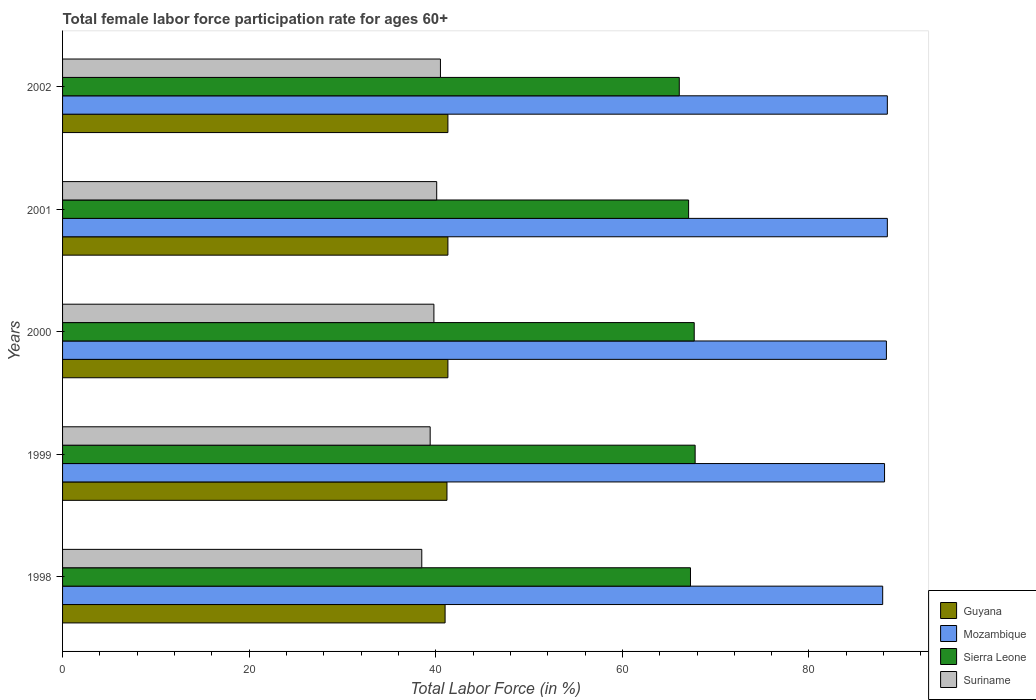How many groups of bars are there?
Your answer should be very brief. 5. Are the number of bars per tick equal to the number of legend labels?
Offer a very short reply. Yes. Are the number of bars on each tick of the Y-axis equal?
Provide a short and direct response. Yes. How many bars are there on the 2nd tick from the top?
Your answer should be very brief. 4. How many bars are there on the 5th tick from the bottom?
Give a very brief answer. 4. In how many cases, is the number of bars for a given year not equal to the number of legend labels?
Offer a very short reply. 0. What is the female labor force participation rate in Sierra Leone in 2000?
Your answer should be compact. 67.7. Across all years, what is the maximum female labor force participation rate in Sierra Leone?
Offer a very short reply. 67.8. Across all years, what is the minimum female labor force participation rate in Mozambique?
Offer a terse response. 87.9. In which year was the female labor force participation rate in Guyana minimum?
Give a very brief answer. 1998. What is the total female labor force participation rate in Guyana in the graph?
Give a very brief answer. 206.1. What is the difference between the female labor force participation rate in Mozambique in 2001 and that in 2002?
Your response must be concise. 0. What is the difference between the female labor force participation rate in Guyana in 1998 and the female labor force participation rate in Mozambique in 1999?
Make the answer very short. -47.1. What is the average female labor force participation rate in Sierra Leone per year?
Provide a succinct answer. 67.2. In the year 1998, what is the difference between the female labor force participation rate in Mozambique and female labor force participation rate in Sierra Leone?
Provide a succinct answer. 20.6. In how many years, is the female labor force participation rate in Guyana greater than 40 %?
Offer a very short reply. 5. What is the ratio of the female labor force participation rate in Guyana in 2000 to that in 2001?
Provide a short and direct response. 1. Is the difference between the female labor force participation rate in Mozambique in 2000 and 2002 greater than the difference between the female labor force participation rate in Sierra Leone in 2000 and 2002?
Your answer should be very brief. No. What is the difference between the highest and the second highest female labor force participation rate in Mozambique?
Your response must be concise. 0. What is the difference between the highest and the lowest female labor force participation rate in Suriname?
Keep it short and to the point. 2. In how many years, is the female labor force participation rate in Sierra Leone greater than the average female labor force participation rate in Sierra Leone taken over all years?
Give a very brief answer. 3. Is it the case that in every year, the sum of the female labor force participation rate in Sierra Leone and female labor force participation rate in Mozambique is greater than the sum of female labor force participation rate in Suriname and female labor force participation rate in Guyana?
Your answer should be compact. Yes. What does the 3rd bar from the top in 2001 represents?
Your answer should be compact. Mozambique. What does the 1st bar from the bottom in 2001 represents?
Offer a very short reply. Guyana. How many years are there in the graph?
Keep it short and to the point. 5. What is the difference between two consecutive major ticks on the X-axis?
Your answer should be compact. 20. Are the values on the major ticks of X-axis written in scientific E-notation?
Give a very brief answer. No. Does the graph contain grids?
Provide a succinct answer. No. Where does the legend appear in the graph?
Offer a very short reply. Bottom right. How many legend labels are there?
Provide a short and direct response. 4. How are the legend labels stacked?
Provide a succinct answer. Vertical. What is the title of the graph?
Make the answer very short. Total female labor force participation rate for ages 60+. What is the Total Labor Force (in %) of Guyana in 1998?
Ensure brevity in your answer.  41. What is the Total Labor Force (in %) in Mozambique in 1998?
Offer a terse response. 87.9. What is the Total Labor Force (in %) of Sierra Leone in 1998?
Your answer should be very brief. 67.3. What is the Total Labor Force (in %) in Suriname in 1998?
Give a very brief answer. 38.5. What is the Total Labor Force (in %) in Guyana in 1999?
Provide a short and direct response. 41.2. What is the Total Labor Force (in %) of Mozambique in 1999?
Give a very brief answer. 88.1. What is the Total Labor Force (in %) of Sierra Leone in 1999?
Provide a succinct answer. 67.8. What is the Total Labor Force (in %) in Suriname in 1999?
Provide a succinct answer. 39.4. What is the Total Labor Force (in %) in Guyana in 2000?
Offer a very short reply. 41.3. What is the Total Labor Force (in %) in Mozambique in 2000?
Provide a short and direct response. 88.3. What is the Total Labor Force (in %) of Sierra Leone in 2000?
Your answer should be very brief. 67.7. What is the Total Labor Force (in %) of Suriname in 2000?
Make the answer very short. 39.8. What is the Total Labor Force (in %) of Guyana in 2001?
Ensure brevity in your answer.  41.3. What is the Total Labor Force (in %) in Mozambique in 2001?
Your response must be concise. 88.4. What is the Total Labor Force (in %) in Sierra Leone in 2001?
Give a very brief answer. 67.1. What is the Total Labor Force (in %) of Suriname in 2001?
Keep it short and to the point. 40.1. What is the Total Labor Force (in %) in Guyana in 2002?
Keep it short and to the point. 41.3. What is the Total Labor Force (in %) of Mozambique in 2002?
Offer a very short reply. 88.4. What is the Total Labor Force (in %) in Sierra Leone in 2002?
Ensure brevity in your answer.  66.1. What is the Total Labor Force (in %) of Suriname in 2002?
Offer a very short reply. 40.5. Across all years, what is the maximum Total Labor Force (in %) of Guyana?
Offer a terse response. 41.3. Across all years, what is the maximum Total Labor Force (in %) of Mozambique?
Keep it short and to the point. 88.4. Across all years, what is the maximum Total Labor Force (in %) in Sierra Leone?
Your response must be concise. 67.8. Across all years, what is the maximum Total Labor Force (in %) of Suriname?
Keep it short and to the point. 40.5. Across all years, what is the minimum Total Labor Force (in %) in Guyana?
Keep it short and to the point. 41. Across all years, what is the minimum Total Labor Force (in %) of Mozambique?
Your answer should be very brief. 87.9. Across all years, what is the minimum Total Labor Force (in %) of Sierra Leone?
Give a very brief answer. 66.1. Across all years, what is the minimum Total Labor Force (in %) in Suriname?
Give a very brief answer. 38.5. What is the total Total Labor Force (in %) in Guyana in the graph?
Give a very brief answer. 206.1. What is the total Total Labor Force (in %) in Mozambique in the graph?
Your response must be concise. 441.1. What is the total Total Labor Force (in %) of Sierra Leone in the graph?
Your answer should be compact. 336. What is the total Total Labor Force (in %) of Suriname in the graph?
Keep it short and to the point. 198.3. What is the difference between the Total Labor Force (in %) of Guyana in 1998 and that in 1999?
Your answer should be very brief. -0.2. What is the difference between the Total Labor Force (in %) of Mozambique in 1998 and that in 1999?
Your response must be concise. -0.2. What is the difference between the Total Labor Force (in %) in Suriname in 1998 and that in 1999?
Provide a succinct answer. -0.9. What is the difference between the Total Labor Force (in %) of Guyana in 1998 and that in 2000?
Ensure brevity in your answer.  -0.3. What is the difference between the Total Labor Force (in %) in Mozambique in 1998 and that in 2000?
Your answer should be compact. -0.4. What is the difference between the Total Labor Force (in %) of Sierra Leone in 1998 and that in 2000?
Offer a very short reply. -0.4. What is the difference between the Total Labor Force (in %) of Guyana in 1998 and that in 2001?
Ensure brevity in your answer.  -0.3. What is the difference between the Total Labor Force (in %) of Sierra Leone in 1998 and that in 2001?
Offer a very short reply. 0.2. What is the difference between the Total Labor Force (in %) in Suriname in 1998 and that in 2001?
Offer a very short reply. -1.6. What is the difference between the Total Labor Force (in %) of Sierra Leone in 1998 and that in 2002?
Keep it short and to the point. 1.2. What is the difference between the Total Labor Force (in %) of Sierra Leone in 1999 and that in 2000?
Provide a short and direct response. 0.1. What is the difference between the Total Labor Force (in %) of Guyana in 1999 and that in 2001?
Your response must be concise. -0.1. What is the difference between the Total Labor Force (in %) in Sierra Leone in 1999 and that in 2001?
Offer a terse response. 0.7. What is the difference between the Total Labor Force (in %) in Guyana in 1999 and that in 2002?
Your answer should be very brief. -0.1. What is the difference between the Total Labor Force (in %) in Mozambique in 1999 and that in 2002?
Ensure brevity in your answer.  -0.3. What is the difference between the Total Labor Force (in %) of Mozambique in 2000 and that in 2001?
Give a very brief answer. -0.1. What is the difference between the Total Labor Force (in %) of Suriname in 2000 and that in 2001?
Your answer should be very brief. -0.3. What is the difference between the Total Labor Force (in %) in Guyana in 2000 and that in 2002?
Ensure brevity in your answer.  0. What is the difference between the Total Labor Force (in %) in Suriname in 2000 and that in 2002?
Provide a succinct answer. -0.7. What is the difference between the Total Labor Force (in %) of Guyana in 2001 and that in 2002?
Provide a succinct answer. 0. What is the difference between the Total Labor Force (in %) in Sierra Leone in 2001 and that in 2002?
Your answer should be very brief. 1. What is the difference between the Total Labor Force (in %) in Suriname in 2001 and that in 2002?
Provide a succinct answer. -0.4. What is the difference between the Total Labor Force (in %) of Guyana in 1998 and the Total Labor Force (in %) of Mozambique in 1999?
Provide a short and direct response. -47.1. What is the difference between the Total Labor Force (in %) of Guyana in 1998 and the Total Labor Force (in %) of Sierra Leone in 1999?
Provide a succinct answer. -26.8. What is the difference between the Total Labor Force (in %) of Mozambique in 1998 and the Total Labor Force (in %) of Sierra Leone in 1999?
Make the answer very short. 20.1. What is the difference between the Total Labor Force (in %) of Mozambique in 1998 and the Total Labor Force (in %) of Suriname in 1999?
Provide a succinct answer. 48.5. What is the difference between the Total Labor Force (in %) in Sierra Leone in 1998 and the Total Labor Force (in %) in Suriname in 1999?
Give a very brief answer. 27.9. What is the difference between the Total Labor Force (in %) in Guyana in 1998 and the Total Labor Force (in %) in Mozambique in 2000?
Keep it short and to the point. -47.3. What is the difference between the Total Labor Force (in %) in Guyana in 1998 and the Total Labor Force (in %) in Sierra Leone in 2000?
Keep it short and to the point. -26.7. What is the difference between the Total Labor Force (in %) in Mozambique in 1998 and the Total Labor Force (in %) in Sierra Leone in 2000?
Make the answer very short. 20.2. What is the difference between the Total Labor Force (in %) in Mozambique in 1998 and the Total Labor Force (in %) in Suriname in 2000?
Offer a very short reply. 48.1. What is the difference between the Total Labor Force (in %) in Sierra Leone in 1998 and the Total Labor Force (in %) in Suriname in 2000?
Your answer should be very brief. 27.5. What is the difference between the Total Labor Force (in %) of Guyana in 1998 and the Total Labor Force (in %) of Mozambique in 2001?
Your response must be concise. -47.4. What is the difference between the Total Labor Force (in %) of Guyana in 1998 and the Total Labor Force (in %) of Sierra Leone in 2001?
Give a very brief answer. -26.1. What is the difference between the Total Labor Force (in %) in Guyana in 1998 and the Total Labor Force (in %) in Suriname in 2001?
Provide a succinct answer. 0.9. What is the difference between the Total Labor Force (in %) in Mozambique in 1998 and the Total Labor Force (in %) in Sierra Leone in 2001?
Make the answer very short. 20.8. What is the difference between the Total Labor Force (in %) of Mozambique in 1998 and the Total Labor Force (in %) of Suriname in 2001?
Your answer should be compact. 47.8. What is the difference between the Total Labor Force (in %) in Sierra Leone in 1998 and the Total Labor Force (in %) in Suriname in 2001?
Your answer should be very brief. 27.2. What is the difference between the Total Labor Force (in %) of Guyana in 1998 and the Total Labor Force (in %) of Mozambique in 2002?
Your response must be concise. -47.4. What is the difference between the Total Labor Force (in %) in Guyana in 1998 and the Total Labor Force (in %) in Sierra Leone in 2002?
Offer a very short reply. -25.1. What is the difference between the Total Labor Force (in %) of Guyana in 1998 and the Total Labor Force (in %) of Suriname in 2002?
Your response must be concise. 0.5. What is the difference between the Total Labor Force (in %) in Mozambique in 1998 and the Total Labor Force (in %) in Sierra Leone in 2002?
Your answer should be very brief. 21.8. What is the difference between the Total Labor Force (in %) in Mozambique in 1998 and the Total Labor Force (in %) in Suriname in 2002?
Your answer should be compact. 47.4. What is the difference between the Total Labor Force (in %) of Sierra Leone in 1998 and the Total Labor Force (in %) of Suriname in 2002?
Your answer should be very brief. 26.8. What is the difference between the Total Labor Force (in %) in Guyana in 1999 and the Total Labor Force (in %) in Mozambique in 2000?
Ensure brevity in your answer.  -47.1. What is the difference between the Total Labor Force (in %) of Guyana in 1999 and the Total Labor Force (in %) of Sierra Leone in 2000?
Offer a very short reply. -26.5. What is the difference between the Total Labor Force (in %) in Guyana in 1999 and the Total Labor Force (in %) in Suriname in 2000?
Ensure brevity in your answer.  1.4. What is the difference between the Total Labor Force (in %) of Mozambique in 1999 and the Total Labor Force (in %) of Sierra Leone in 2000?
Your answer should be compact. 20.4. What is the difference between the Total Labor Force (in %) in Mozambique in 1999 and the Total Labor Force (in %) in Suriname in 2000?
Your response must be concise. 48.3. What is the difference between the Total Labor Force (in %) in Guyana in 1999 and the Total Labor Force (in %) in Mozambique in 2001?
Provide a short and direct response. -47.2. What is the difference between the Total Labor Force (in %) of Guyana in 1999 and the Total Labor Force (in %) of Sierra Leone in 2001?
Your answer should be very brief. -25.9. What is the difference between the Total Labor Force (in %) of Mozambique in 1999 and the Total Labor Force (in %) of Suriname in 2001?
Keep it short and to the point. 48. What is the difference between the Total Labor Force (in %) of Sierra Leone in 1999 and the Total Labor Force (in %) of Suriname in 2001?
Your answer should be compact. 27.7. What is the difference between the Total Labor Force (in %) in Guyana in 1999 and the Total Labor Force (in %) in Mozambique in 2002?
Provide a short and direct response. -47.2. What is the difference between the Total Labor Force (in %) in Guyana in 1999 and the Total Labor Force (in %) in Sierra Leone in 2002?
Give a very brief answer. -24.9. What is the difference between the Total Labor Force (in %) of Guyana in 1999 and the Total Labor Force (in %) of Suriname in 2002?
Provide a succinct answer. 0.7. What is the difference between the Total Labor Force (in %) of Mozambique in 1999 and the Total Labor Force (in %) of Suriname in 2002?
Offer a very short reply. 47.6. What is the difference between the Total Labor Force (in %) of Sierra Leone in 1999 and the Total Labor Force (in %) of Suriname in 2002?
Keep it short and to the point. 27.3. What is the difference between the Total Labor Force (in %) of Guyana in 2000 and the Total Labor Force (in %) of Mozambique in 2001?
Provide a succinct answer. -47.1. What is the difference between the Total Labor Force (in %) in Guyana in 2000 and the Total Labor Force (in %) in Sierra Leone in 2001?
Keep it short and to the point. -25.8. What is the difference between the Total Labor Force (in %) in Guyana in 2000 and the Total Labor Force (in %) in Suriname in 2001?
Your response must be concise. 1.2. What is the difference between the Total Labor Force (in %) of Mozambique in 2000 and the Total Labor Force (in %) of Sierra Leone in 2001?
Give a very brief answer. 21.2. What is the difference between the Total Labor Force (in %) of Mozambique in 2000 and the Total Labor Force (in %) of Suriname in 2001?
Provide a short and direct response. 48.2. What is the difference between the Total Labor Force (in %) in Sierra Leone in 2000 and the Total Labor Force (in %) in Suriname in 2001?
Ensure brevity in your answer.  27.6. What is the difference between the Total Labor Force (in %) in Guyana in 2000 and the Total Labor Force (in %) in Mozambique in 2002?
Keep it short and to the point. -47.1. What is the difference between the Total Labor Force (in %) in Guyana in 2000 and the Total Labor Force (in %) in Sierra Leone in 2002?
Provide a succinct answer. -24.8. What is the difference between the Total Labor Force (in %) of Guyana in 2000 and the Total Labor Force (in %) of Suriname in 2002?
Your response must be concise. 0.8. What is the difference between the Total Labor Force (in %) of Mozambique in 2000 and the Total Labor Force (in %) of Sierra Leone in 2002?
Your answer should be very brief. 22.2. What is the difference between the Total Labor Force (in %) of Mozambique in 2000 and the Total Labor Force (in %) of Suriname in 2002?
Ensure brevity in your answer.  47.8. What is the difference between the Total Labor Force (in %) of Sierra Leone in 2000 and the Total Labor Force (in %) of Suriname in 2002?
Make the answer very short. 27.2. What is the difference between the Total Labor Force (in %) in Guyana in 2001 and the Total Labor Force (in %) in Mozambique in 2002?
Offer a terse response. -47.1. What is the difference between the Total Labor Force (in %) of Guyana in 2001 and the Total Labor Force (in %) of Sierra Leone in 2002?
Keep it short and to the point. -24.8. What is the difference between the Total Labor Force (in %) in Mozambique in 2001 and the Total Labor Force (in %) in Sierra Leone in 2002?
Your answer should be compact. 22.3. What is the difference between the Total Labor Force (in %) of Mozambique in 2001 and the Total Labor Force (in %) of Suriname in 2002?
Your response must be concise. 47.9. What is the difference between the Total Labor Force (in %) in Sierra Leone in 2001 and the Total Labor Force (in %) in Suriname in 2002?
Your response must be concise. 26.6. What is the average Total Labor Force (in %) of Guyana per year?
Ensure brevity in your answer.  41.22. What is the average Total Labor Force (in %) of Mozambique per year?
Keep it short and to the point. 88.22. What is the average Total Labor Force (in %) in Sierra Leone per year?
Ensure brevity in your answer.  67.2. What is the average Total Labor Force (in %) in Suriname per year?
Your answer should be compact. 39.66. In the year 1998, what is the difference between the Total Labor Force (in %) in Guyana and Total Labor Force (in %) in Mozambique?
Your response must be concise. -46.9. In the year 1998, what is the difference between the Total Labor Force (in %) of Guyana and Total Labor Force (in %) of Sierra Leone?
Provide a short and direct response. -26.3. In the year 1998, what is the difference between the Total Labor Force (in %) in Guyana and Total Labor Force (in %) in Suriname?
Keep it short and to the point. 2.5. In the year 1998, what is the difference between the Total Labor Force (in %) in Mozambique and Total Labor Force (in %) in Sierra Leone?
Ensure brevity in your answer.  20.6. In the year 1998, what is the difference between the Total Labor Force (in %) of Mozambique and Total Labor Force (in %) of Suriname?
Offer a very short reply. 49.4. In the year 1998, what is the difference between the Total Labor Force (in %) of Sierra Leone and Total Labor Force (in %) of Suriname?
Provide a short and direct response. 28.8. In the year 1999, what is the difference between the Total Labor Force (in %) of Guyana and Total Labor Force (in %) of Mozambique?
Your response must be concise. -46.9. In the year 1999, what is the difference between the Total Labor Force (in %) in Guyana and Total Labor Force (in %) in Sierra Leone?
Make the answer very short. -26.6. In the year 1999, what is the difference between the Total Labor Force (in %) of Mozambique and Total Labor Force (in %) of Sierra Leone?
Give a very brief answer. 20.3. In the year 1999, what is the difference between the Total Labor Force (in %) in Mozambique and Total Labor Force (in %) in Suriname?
Provide a succinct answer. 48.7. In the year 1999, what is the difference between the Total Labor Force (in %) of Sierra Leone and Total Labor Force (in %) of Suriname?
Offer a terse response. 28.4. In the year 2000, what is the difference between the Total Labor Force (in %) in Guyana and Total Labor Force (in %) in Mozambique?
Provide a short and direct response. -47. In the year 2000, what is the difference between the Total Labor Force (in %) in Guyana and Total Labor Force (in %) in Sierra Leone?
Your answer should be very brief. -26.4. In the year 2000, what is the difference between the Total Labor Force (in %) of Guyana and Total Labor Force (in %) of Suriname?
Offer a terse response. 1.5. In the year 2000, what is the difference between the Total Labor Force (in %) of Mozambique and Total Labor Force (in %) of Sierra Leone?
Ensure brevity in your answer.  20.6. In the year 2000, what is the difference between the Total Labor Force (in %) in Mozambique and Total Labor Force (in %) in Suriname?
Provide a short and direct response. 48.5. In the year 2000, what is the difference between the Total Labor Force (in %) in Sierra Leone and Total Labor Force (in %) in Suriname?
Provide a succinct answer. 27.9. In the year 2001, what is the difference between the Total Labor Force (in %) of Guyana and Total Labor Force (in %) of Mozambique?
Ensure brevity in your answer.  -47.1. In the year 2001, what is the difference between the Total Labor Force (in %) of Guyana and Total Labor Force (in %) of Sierra Leone?
Ensure brevity in your answer.  -25.8. In the year 2001, what is the difference between the Total Labor Force (in %) of Mozambique and Total Labor Force (in %) of Sierra Leone?
Give a very brief answer. 21.3. In the year 2001, what is the difference between the Total Labor Force (in %) in Mozambique and Total Labor Force (in %) in Suriname?
Your response must be concise. 48.3. In the year 2001, what is the difference between the Total Labor Force (in %) of Sierra Leone and Total Labor Force (in %) of Suriname?
Offer a terse response. 27. In the year 2002, what is the difference between the Total Labor Force (in %) of Guyana and Total Labor Force (in %) of Mozambique?
Make the answer very short. -47.1. In the year 2002, what is the difference between the Total Labor Force (in %) in Guyana and Total Labor Force (in %) in Sierra Leone?
Your response must be concise. -24.8. In the year 2002, what is the difference between the Total Labor Force (in %) in Guyana and Total Labor Force (in %) in Suriname?
Provide a short and direct response. 0.8. In the year 2002, what is the difference between the Total Labor Force (in %) of Mozambique and Total Labor Force (in %) of Sierra Leone?
Offer a terse response. 22.3. In the year 2002, what is the difference between the Total Labor Force (in %) of Mozambique and Total Labor Force (in %) of Suriname?
Your answer should be compact. 47.9. In the year 2002, what is the difference between the Total Labor Force (in %) of Sierra Leone and Total Labor Force (in %) of Suriname?
Your response must be concise. 25.6. What is the ratio of the Total Labor Force (in %) of Sierra Leone in 1998 to that in 1999?
Provide a short and direct response. 0.99. What is the ratio of the Total Labor Force (in %) of Suriname in 1998 to that in 1999?
Provide a succinct answer. 0.98. What is the ratio of the Total Labor Force (in %) in Guyana in 1998 to that in 2000?
Offer a very short reply. 0.99. What is the ratio of the Total Labor Force (in %) in Suriname in 1998 to that in 2000?
Your answer should be compact. 0.97. What is the ratio of the Total Labor Force (in %) in Suriname in 1998 to that in 2001?
Provide a succinct answer. 0.96. What is the ratio of the Total Labor Force (in %) in Guyana in 1998 to that in 2002?
Provide a succinct answer. 0.99. What is the ratio of the Total Labor Force (in %) of Mozambique in 1998 to that in 2002?
Your answer should be compact. 0.99. What is the ratio of the Total Labor Force (in %) of Sierra Leone in 1998 to that in 2002?
Your answer should be very brief. 1.02. What is the ratio of the Total Labor Force (in %) in Suriname in 1998 to that in 2002?
Your answer should be very brief. 0.95. What is the ratio of the Total Labor Force (in %) of Guyana in 1999 to that in 2000?
Give a very brief answer. 1. What is the ratio of the Total Labor Force (in %) of Mozambique in 1999 to that in 2000?
Provide a short and direct response. 1. What is the ratio of the Total Labor Force (in %) in Suriname in 1999 to that in 2000?
Provide a succinct answer. 0.99. What is the ratio of the Total Labor Force (in %) of Guyana in 1999 to that in 2001?
Offer a very short reply. 1. What is the ratio of the Total Labor Force (in %) in Mozambique in 1999 to that in 2001?
Keep it short and to the point. 1. What is the ratio of the Total Labor Force (in %) of Sierra Leone in 1999 to that in 2001?
Your response must be concise. 1.01. What is the ratio of the Total Labor Force (in %) in Suriname in 1999 to that in 2001?
Your answer should be compact. 0.98. What is the ratio of the Total Labor Force (in %) in Mozambique in 1999 to that in 2002?
Your answer should be compact. 1. What is the ratio of the Total Labor Force (in %) in Sierra Leone in 1999 to that in 2002?
Provide a succinct answer. 1.03. What is the ratio of the Total Labor Force (in %) of Suriname in 1999 to that in 2002?
Offer a very short reply. 0.97. What is the ratio of the Total Labor Force (in %) in Guyana in 2000 to that in 2001?
Offer a very short reply. 1. What is the ratio of the Total Labor Force (in %) in Sierra Leone in 2000 to that in 2001?
Offer a terse response. 1.01. What is the ratio of the Total Labor Force (in %) in Suriname in 2000 to that in 2001?
Keep it short and to the point. 0.99. What is the ratio of the Total Labor Force (in %) in Mozambique in 2000 to that in 2002?
Your answer should be compact. 1. What is the ratio of the Total Labor Force (in %) in Sierra Leone in 2000 to that in 2002?
Ensure brevity in your answer.  1.02. What is the ratio of the Total Labor Force (in %) in Suriname in 2000 to that in 2002?
Make the answer very short. 0.98. What is the ratio of the Total Labor Force (in %) in Mozambique in 2001 to that in 2002?
Make the answer very short. 1. What is the ratio of the Total Labor Force (in %) in Sierra Leone in 2001 to that in 2002?
Ensure brevity in your answer.  1.02. What is the ratio of the Total Labor Force (in %) in Suriname in 2001 to that in 2002?
Provide a succinct answer. 0.99. What is the difference between the highest and the second highest Total Labor Force (in %) of Mozambique?
Offer a very short reply. 0. What is the difference between the highest and the second highest Total Labor Force (in %) in Sierra Leone?
Your answer should be very brief. 0.1. What is the difference between the highest and the second highest Total Labor Force (in %) in Suriname?
Offer a very short reply. 0.4. What is the difference between the highest and the lowest Total Labor Force (in %) of Sierra Leone?
Provide a succinct answer. 1.7. 